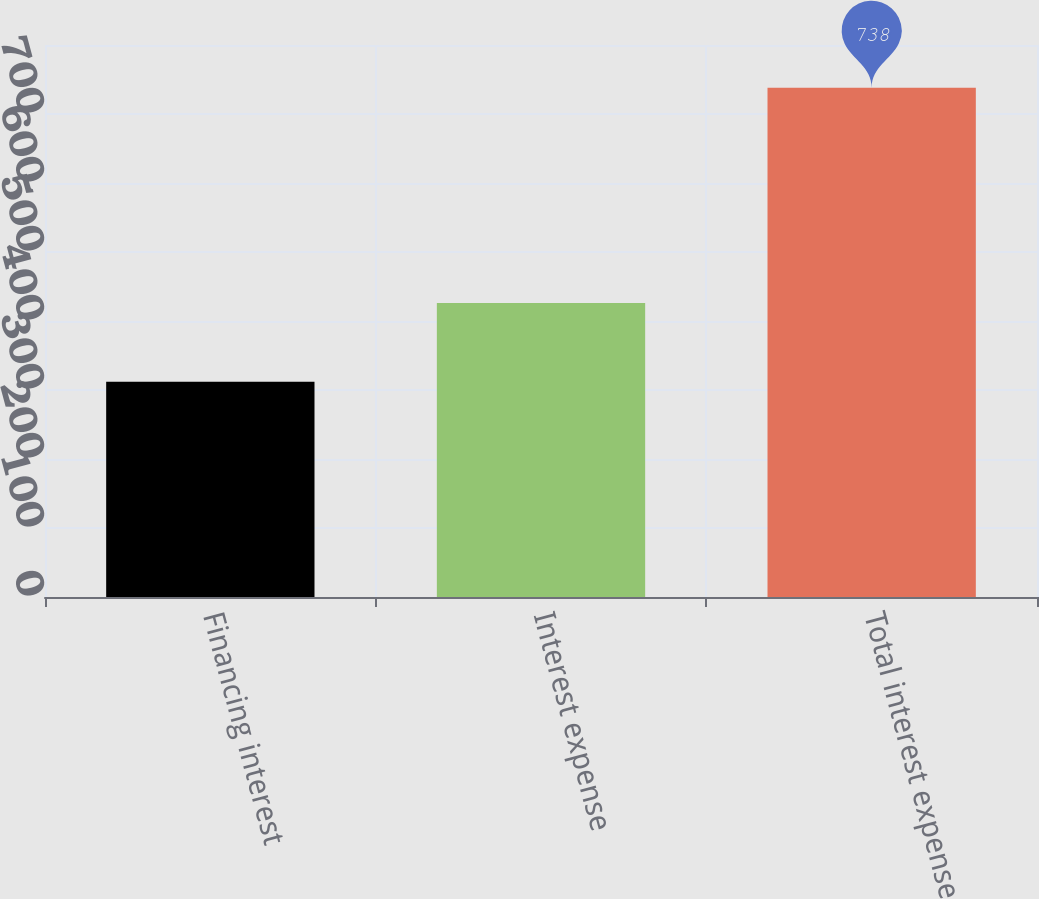<chart> <loc_0><loc_0><loc_500><loc_500><bar_chart><fcel>Financing interest<fcel>Interest expense<fcel>Total interest expense<nl><fcel>312<fcel>426<fcel>738<nl></chart> 